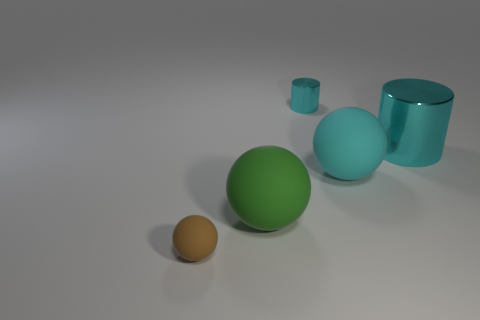Is the shape of the tiny object that is behind the brown ball the same as  the tiny brown matte object?
Provide a short and direct response. No. Are there fewer matte balls that are in front of the brown sphere than cyan balls left of the tiny cyan cylinder?
Your response must be concise. No. What is the material of the cyan thing behind the large cyan cylinder?
Offer a terse response. Metal. There is a ball that is the same color as the big metallic object; what is its size?
Ensure brevity in your answer.  Large. Is there a yellow metallic ball that has the same size as the cyan sphere?
Offer a very short reply. No. There is a cyan matte thing; does it have the same shape as the small thing that is on the right side of the brown ball?
Make the answer very short. No. Do the ball that is to the left of the big green rubber thing and the shiny cylinder that is on the right side of the cyan rubber sphere have the same size?
Provide a succinct answer. No. What number of other objects are the same shape as the brown object?
Keep it short and to the point. 2. There is a large thing that is to the left of the cyan metallic cylinder on the left side of the large cyan ball; what is its material?
Give a very brief answer. Rubber. How many metal things are either large balls or cyan things?
Give a very brief answer. 2. 